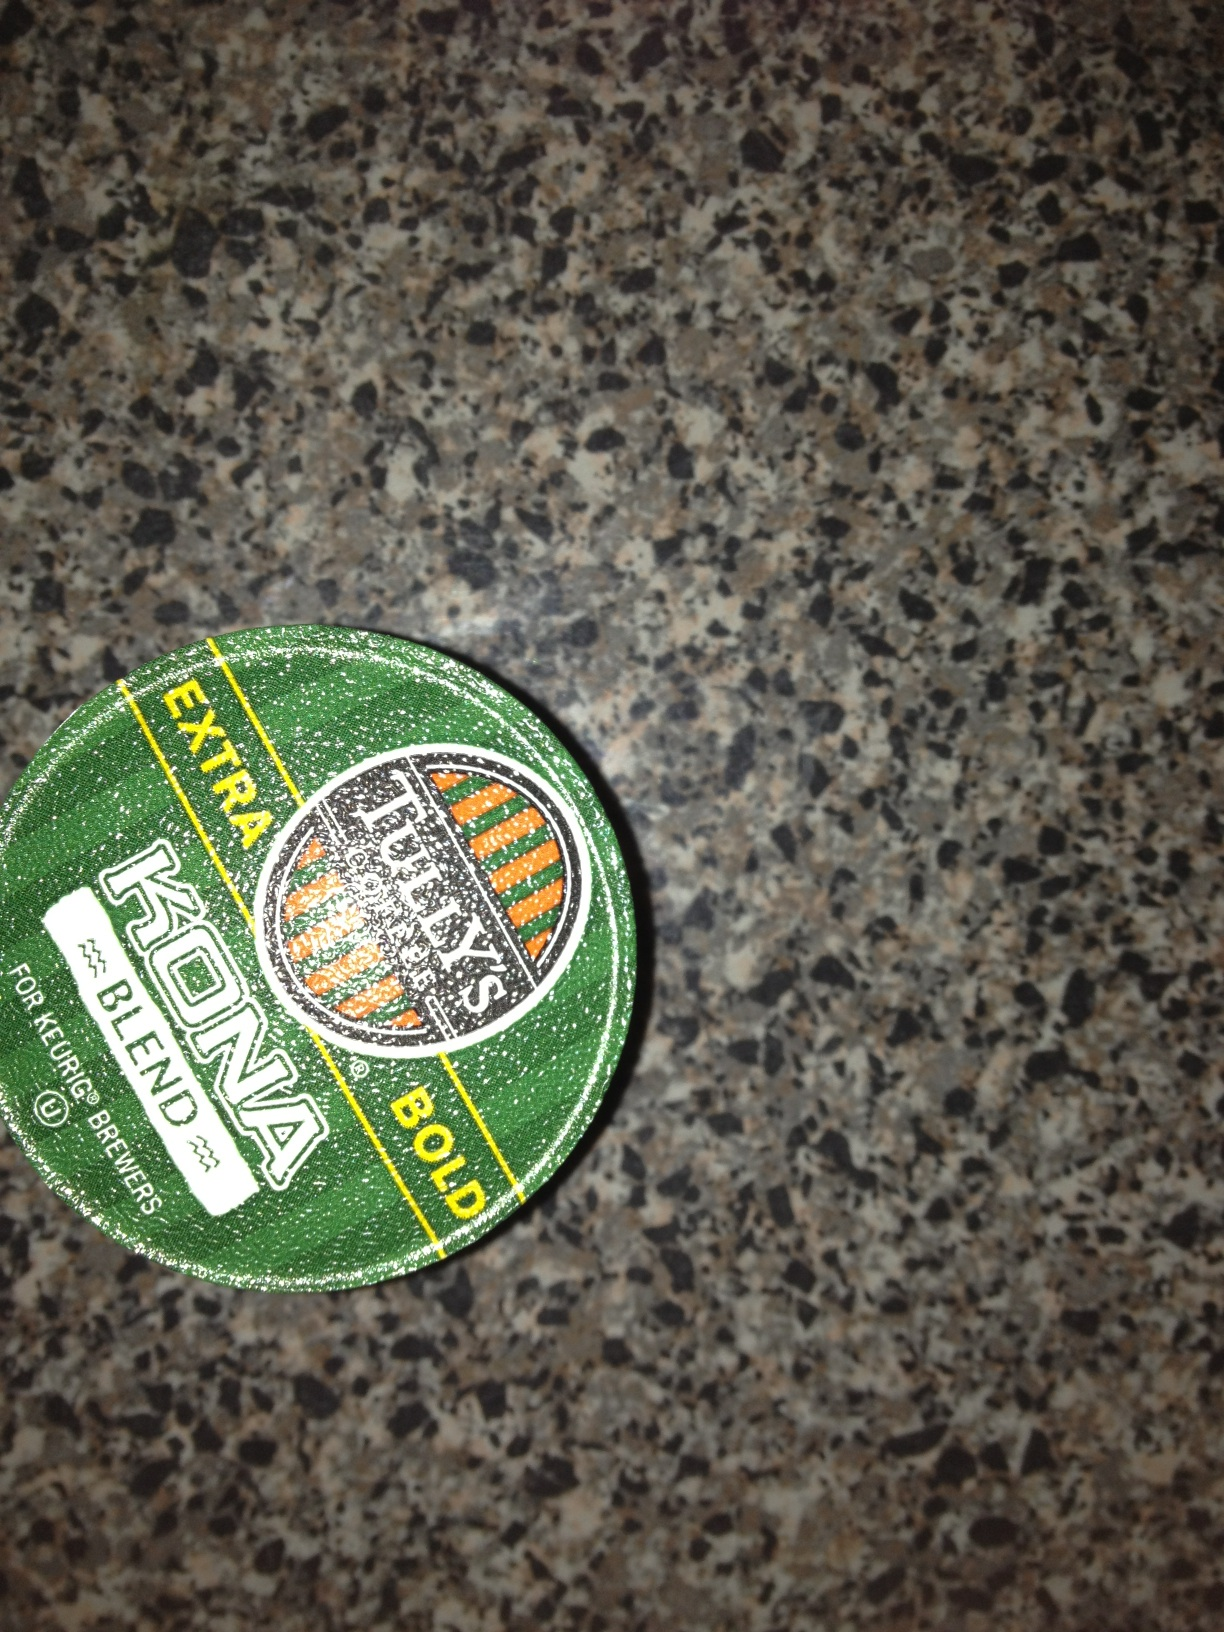Can you explain what makes Kona coffee special? Kona coffee is prized globally for its rich aroma and smooth taste. It's grown in the North and South districts of Kona, on the Big Island of Hawaii, where the unique volcanic soil and favorable climatic conditions impart a distinct flavor that's both mild and sweet, often with hints of spices and nuts. Are there different roast levels available for Kona coffee blends? Yes, Kona coffee is available in various roast levels, from light to dark. Each roast level can significantly affect the flavor profile, with lighter roasts tending to retain more of the original floral and fruity notes, while darker roasts bring out richer, more toasted flavors. 